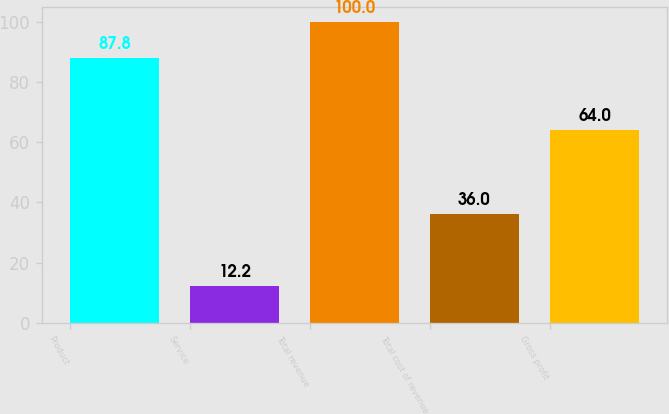Convert chart to OTSL. <chart><loc_0><loc_0><loc_500><loc_500><bar_chart><fcel>Product<fcel>Service<fcel>Total revenue<fcel>Total cost of revenue<fcel>Gross profit<nl><fcel>87.8<fcel>12.2<fcel>100<fcel>36<fcel>64<nl></chart> 